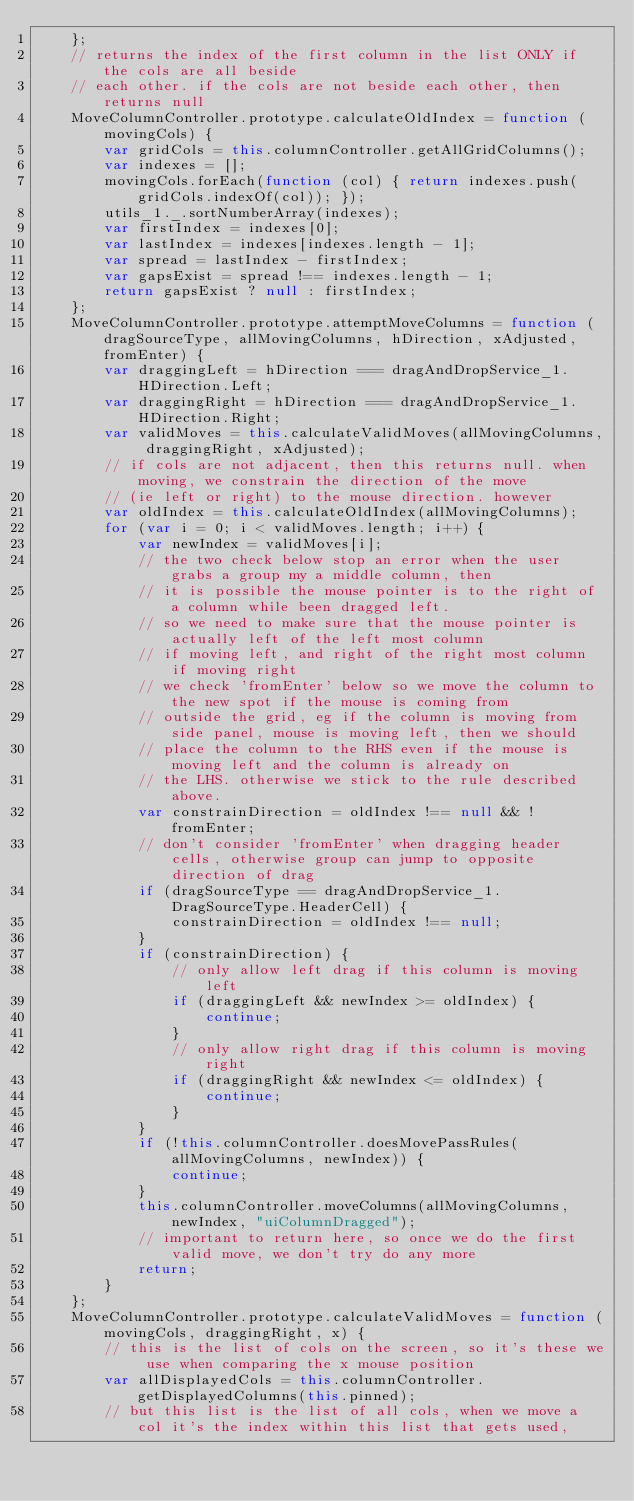<code> <loc_0><loc_0><loc_500><loc_500><_JavaScript_>    };
    // returns the index of the first column in the list ONLY if the cols are all beside
    // each other. if the cols are not beside each other, then returns null
    MoveColumnController.prototype.calculateOldIndex = function (movingCols) {
        var gridCols = this.columnController.getAllGridColumns();
        var indexes = [];
        movingCols.forEach(function (col) { return indexes.push(gridCols.indexOf(col)); });
        utils_1._.sortNumberArray(indexes);
        var firstIndex = indexes[0];
        var lastIndex = indexes[indexes.length - 1];
        var spread = lastIndex - firstIndex;
        var gapsExist = spread !== indexes.length - 1;
        return gapsExist ? null : firstIndex;
    };
    MoveColumnController.prototype.attemptMoveColumns = function (dragSourceType, allMovingColumns, hDirection, xAdjusted, fromEnter) {
        var draggingLeft = hDirection === dragAndDropService_1.HDirection.Left;
        var draggingRight = hDirection === dragAndDropService_1.HDirection.Right;
        var validMoves = this.calculateValidMoves(allMovingColumns, draggingRight, xAdjusted);
        // if cols are not adjacent, then this returns null. when moving, we constrain the direction of the move
        // (ie left or right) to the mouse direction. however
        var oldIndex = this.calculateOldIndex(allMovingColumns);
        for (var i = 0; i < validMoves.length; i++) {
            var newIndex = validMoves[i];
            // the two check below stop an error when the user grabs a group my a middle column, then
            // it is possible the mouse pointer is to the right of a column while been dragged left.
            // so we need to make sure that the mouse pointer is actually left of the left most column
            // if moving left, and right of the right most column if moving right
            // we check 'fromEnter' below so we move the column to the new spot if the mouse is coming from
            // outside the grid, eg if the column is moving from side panel, mouse is moving left, then we should
            // place the column to the RHS even if the mouse is moving left and the column is already on
            // the LHS. otherwise we stick to the rule described above.
            var constrainDirection = oldIndex !== null && !fromEnter;
            // don't consider 'fromEnter' when dragging header cells, otherwise group can jump to opposite direction of drag
            if (dragSourceType == dragAndDropService_1.DragSourceType.HeaderCell) {
                constrainDirection = oldIndex !== null;
            }
            if (constrainDirection) {
                // only allow left drag if this column is moving left
                if (draggingLeft && newIndex >= oldIndex) {
                    continue;
                }
                // only allow right drag if this column is moving right
                if (draggingRight && newIndex <= oldIndex) {
                    continue;
                }
            }
            if (!this.columnController.doesMovePassRules(allMovingColumns, newIndex)) {
                continue;
            }
            this.columnController.moveColumns(allMovingColumns, newIndex, "uiColumnDragged");
            // important to return here, so once we do the first valid move, we don't try do any more
            return;
        }
    };
    MoveColumnController.prototype.calculateValidMoves = function (movingCols, draggingRight, x) {
        // this is the list of cols on the screen, so it's these we use when comparing the x mouse position
        var allDisplayedCols = this.columnController.getDisplayedColumns(this.pinned);
        // but this list is the list of all cols, when we move a col it's the index within this list that gets used,</code> 